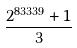Convert formula to latex. <formula><loc_0><loc_0><loc_500><loc_500>\frac { 2 ^ { 8 3 3 3 9 } + 1 } { 3 }</formula> 